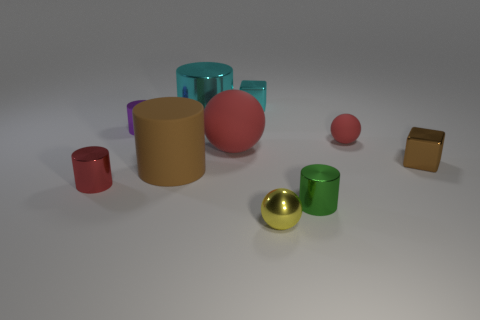Subtract all red matte balls. How many balls are left? 1 Subtract all cyan cylinders. How many cylinders are left? 4 Subtract 1 spheres. How many spheres are left? 2 Subtract all red cylinders. Subtract all cyan spheres. How many cylinders are left? 4 Subtract all balls. How many objects are left? 7 Add 8 big blue metal spheres. How many big blue metal spheres exist? 8 Subtract 0 purple blocks. How many objects are left? 10 Subtract all brown objects. Subtract all big red spheres. How many objects are left? 7 Add 6 small yellow balls. How many small yellow balls are left? 7 